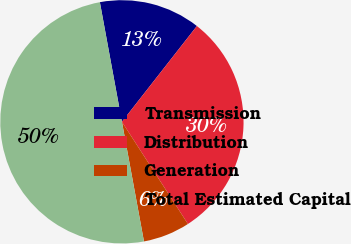Convert chart. <chart><loc_0><loc_0><loc_500><loc_500><pie_chart><fcel>Transmission<fcel>Distribution<fcel>Generation<fcel>Total Estimated Capital<nl><fcel>13.47%<fcel>30.3%<fcel>6.23%<fcel>50.0%<nl></chart> 